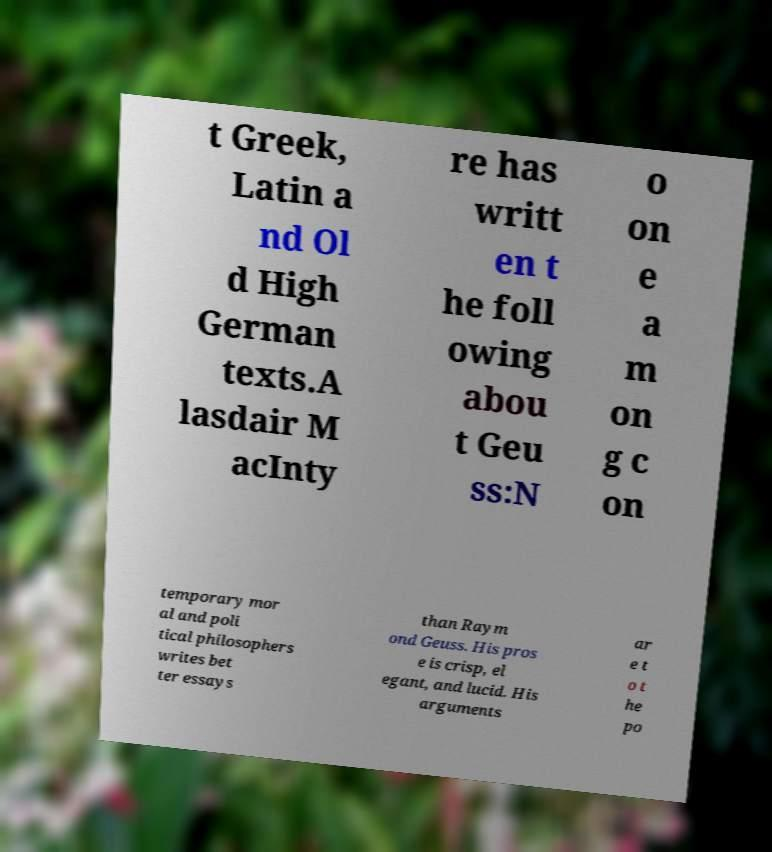I need the written content from this picture converted into text. Can you do that? t Greek, Latin a nd Ol d High German texts.A lasdair M acInty re has writt en t he foll owing abou t Geu ss:N o on e a m on g c on temporary mor al and poli tical philosophers writes bet ter essays than Raym ond Geuss. His pros e is crisp, el egant, and lucid. His arguments ar e t o t he po 